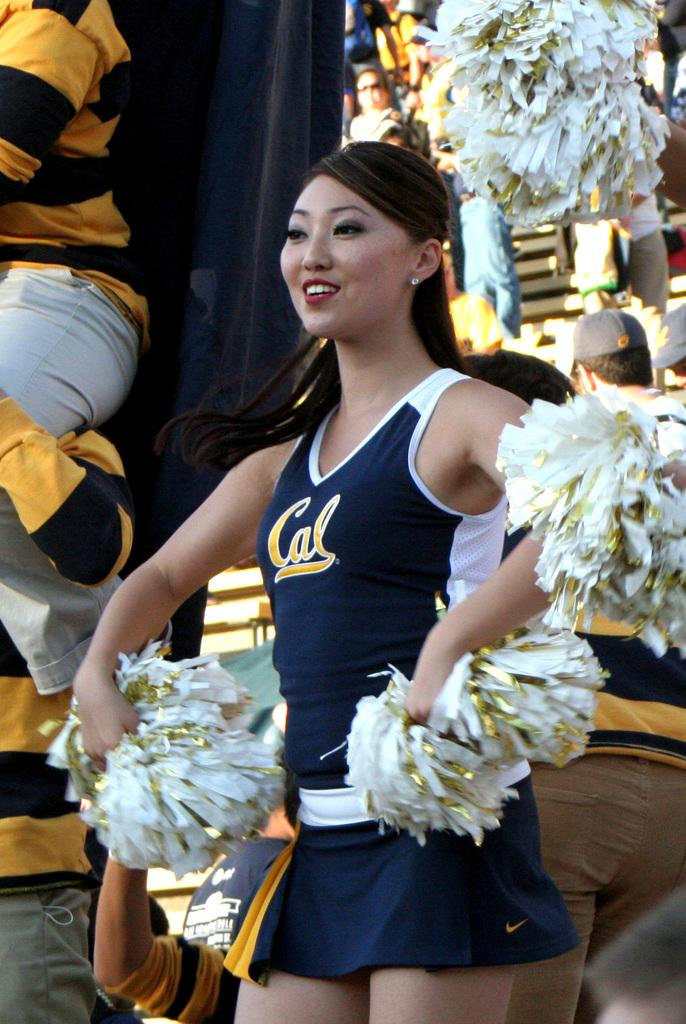<image>
Describe the image concisely. The beautiful cheerleader is wearing a top that says Cal. 